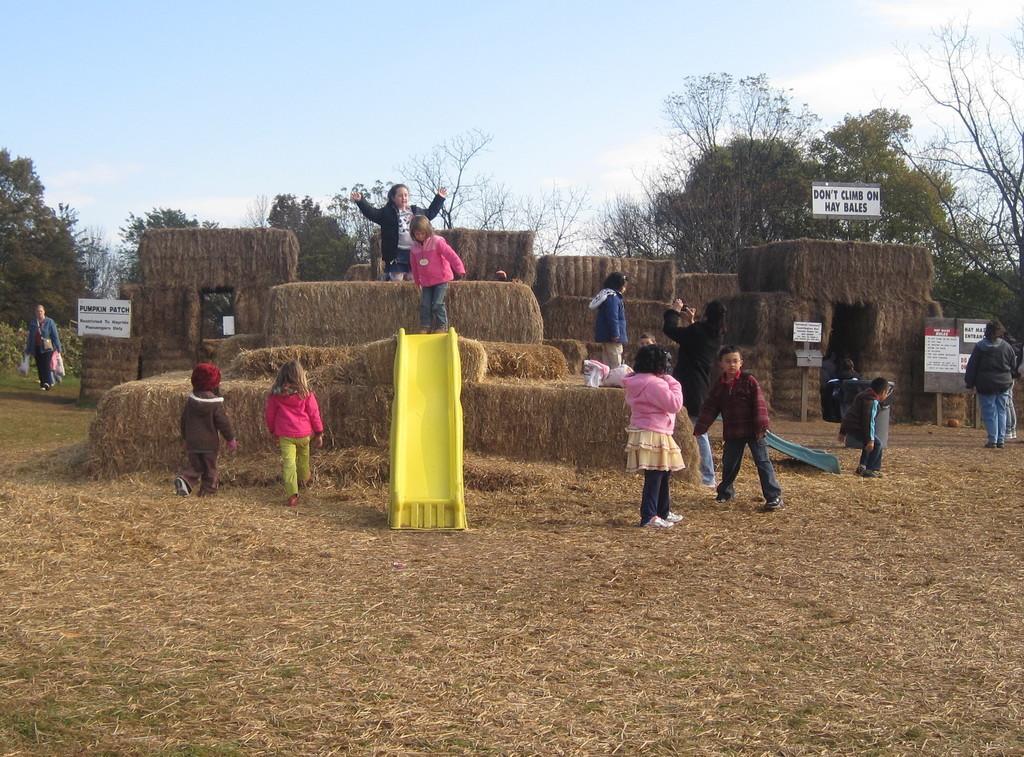Can you describe this image briefly? In this image we can see a group of people standing on the haystack. On the left side we can see a person carrying bags. We can also see the slides, a group of people standing on the ground, some boards with text on it, some huts built with dried grass, a group of trees, plants and the sky which looks cloudy. 